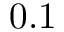Convert formula to latex. <formula><loc_0><loc_0><loc_500><loc_500>0 . 1</formula> 